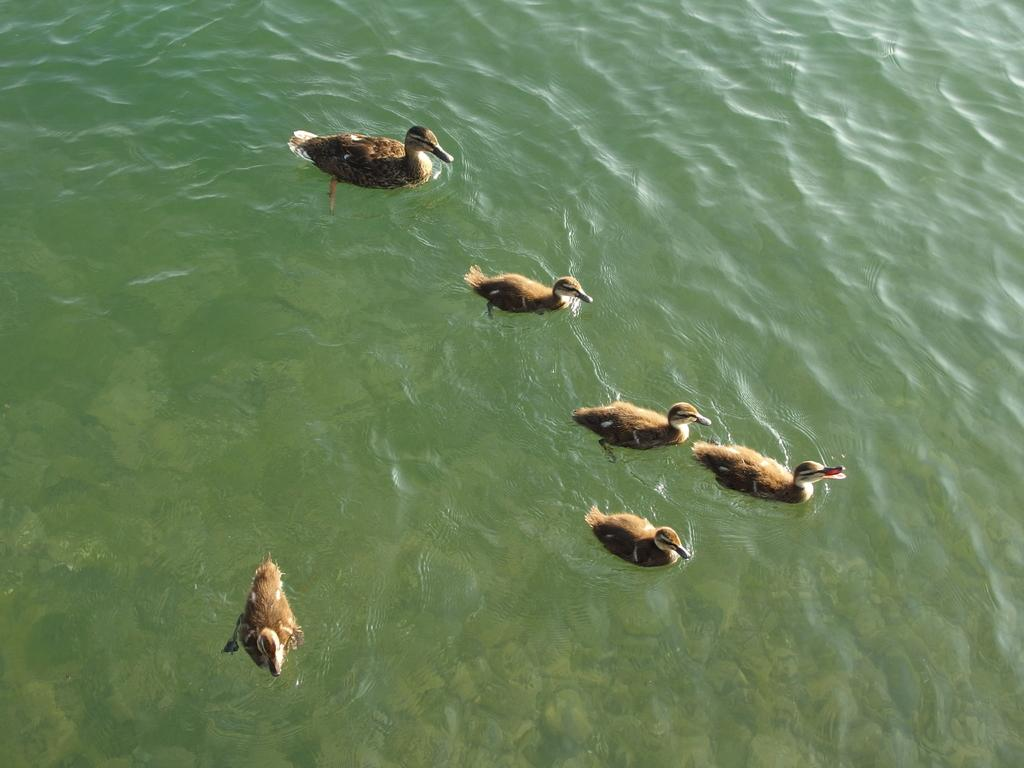What type of animals are in the image? There are ducks in the image. Where are the ducks located? The ducks are in the water. What type of pen is being used during the discussion in the image? There is no pen or discussion present in the image; it features ducks in the water. 